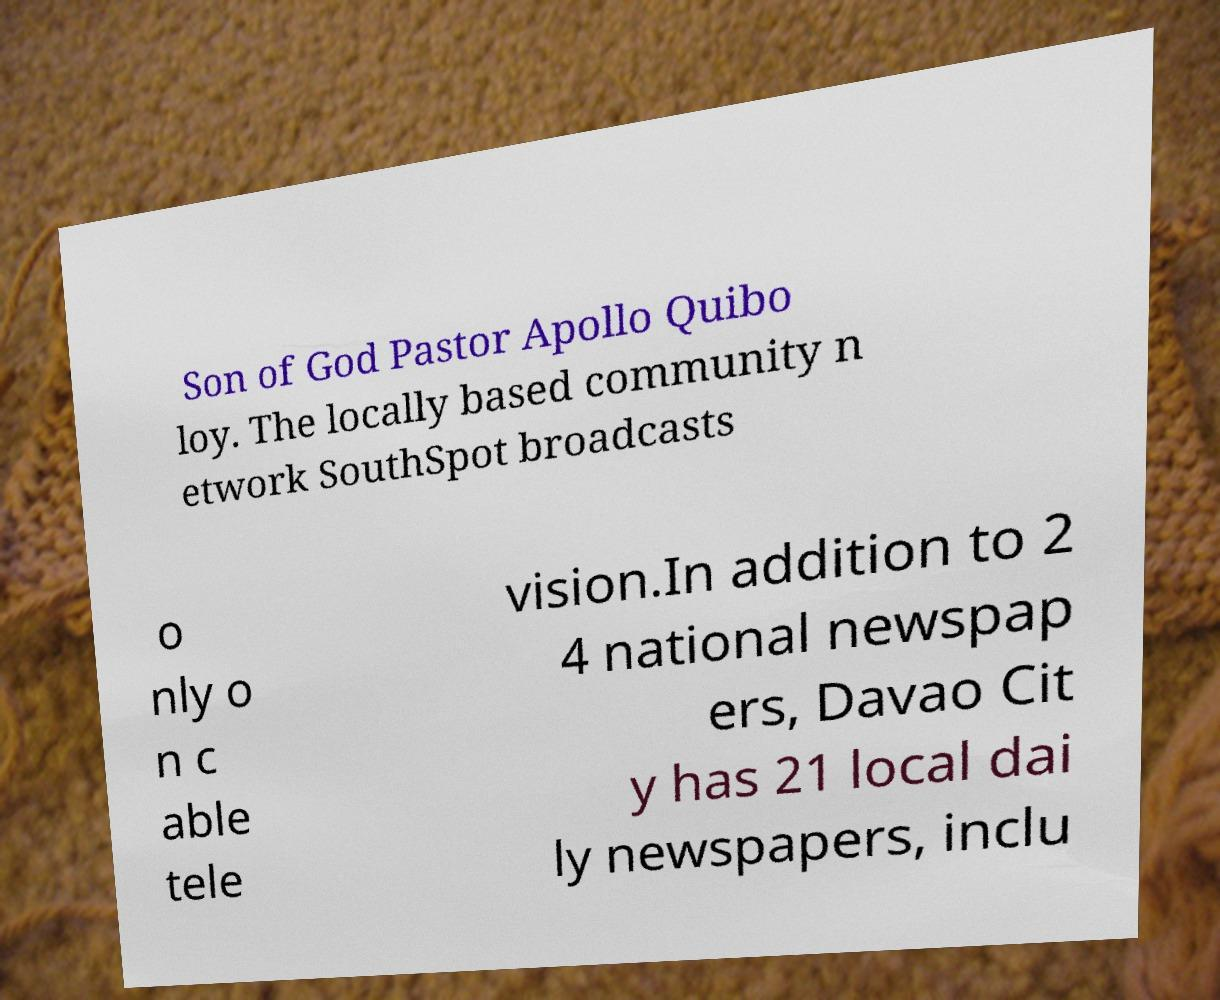What messages or text are displayed in this image? I need them in a readable, typed format. Son of God Pastor Apollo Quibo loy. The locally based community n etwork SouthSpot broadcasts o nly o n c able tele vision.In addition to 2 4 national newspap ers, Davao Cit y has 21 local dai ly newspapers, inclu 